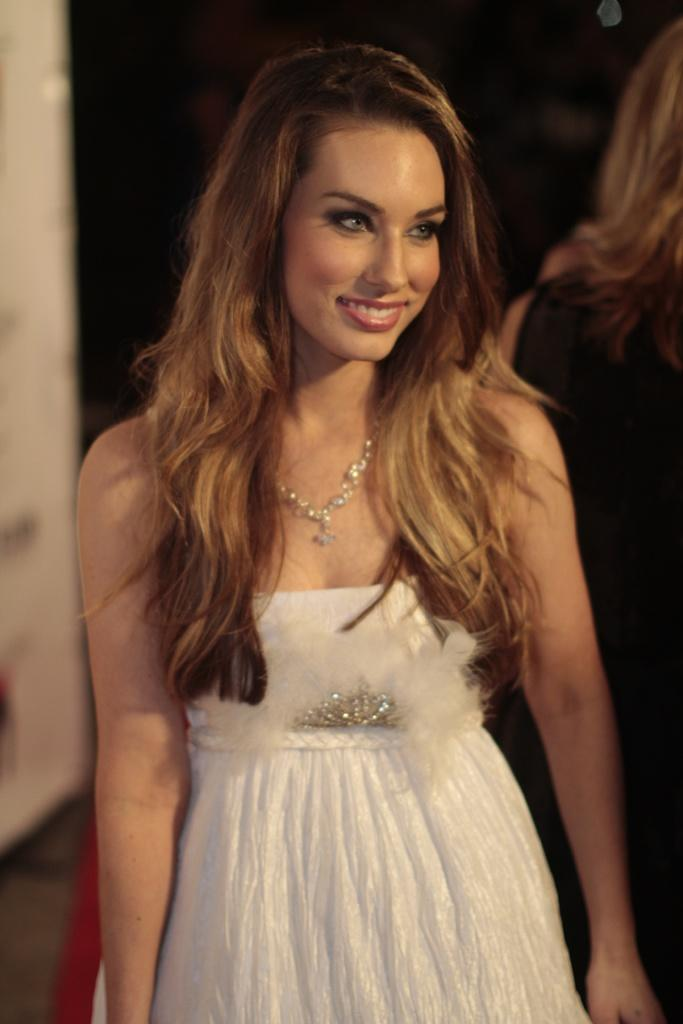What is the main subject of the image? There is a person in the image. Can you describe the person's appearance? The person is wearing clothes. What can be observed about the background of the image? The background of the image is blurred. What type of wheel can be seen in the image? There is no wheel present in the image. How does the person stretch in the image? The person is not stretching in the image; they are simply standing or sitting. 